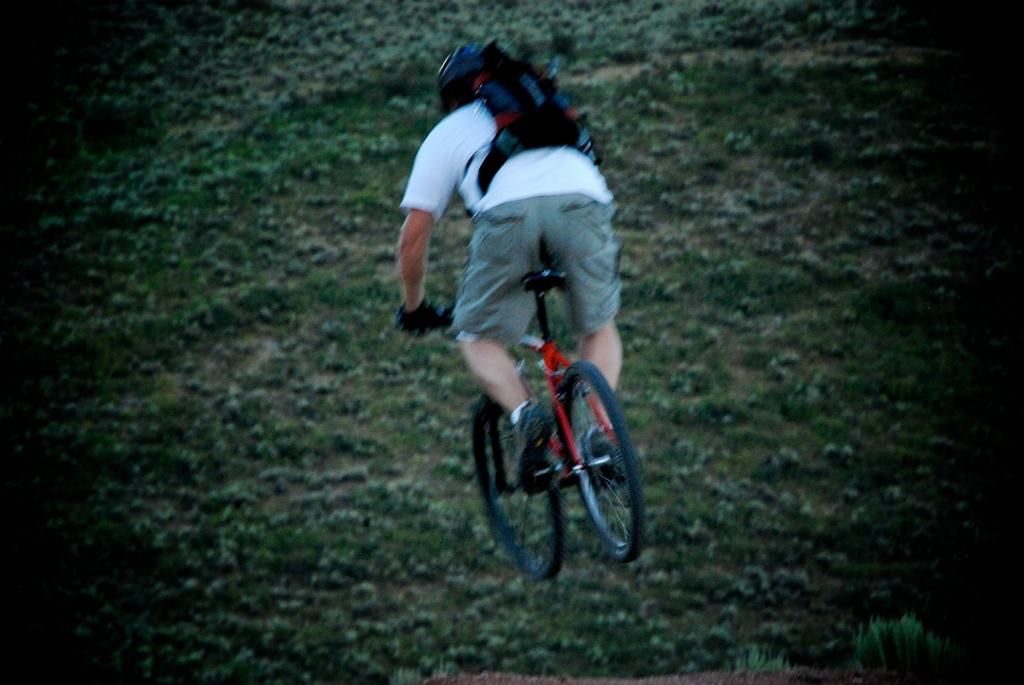What is the main subject of the image? There is a person in the image. What is the person doing in the image? The person is riding a bicycle. Can you describe any additional items the person is carrying? The person has a bag on their backpack. Is the person riding the bicycle through quicksand in the image? No, there is no quicksand present in the image. What type of cap is the person wearing in the image? There is no cap visible in the image. 